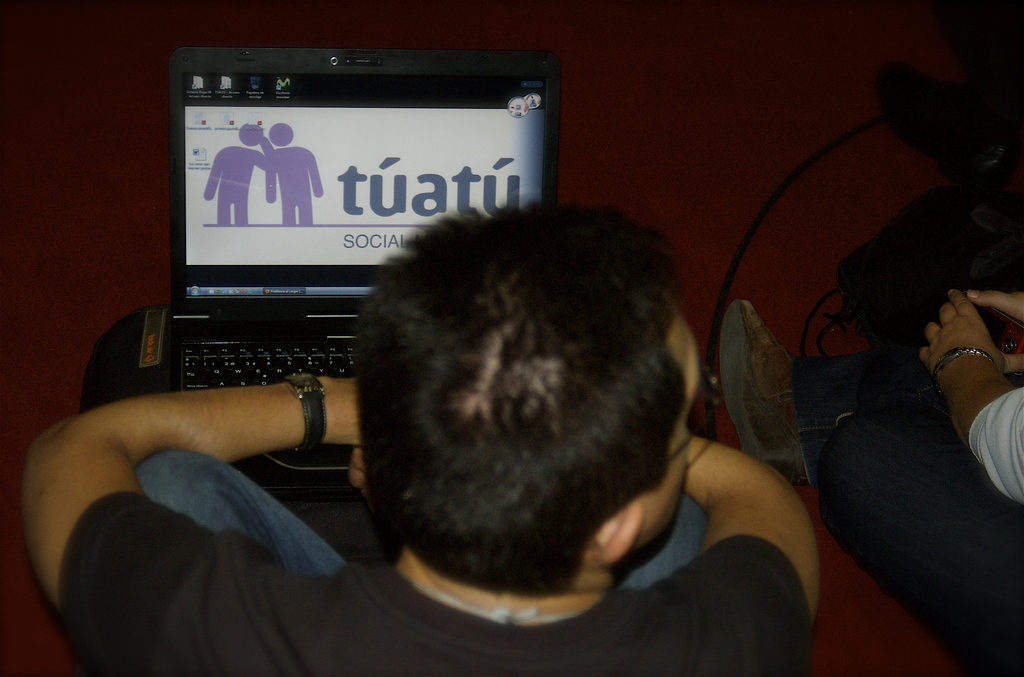Describe the setting in which the man is using his laptop. The man is seated in a casual, possibly public setting with a carpeted floor and ambient lighting, indicative of a relaxed environment like a lounge or a student common area. Does the setting seem to affect his interaction with the website? The relaxed setting likely promotes a comfortable browsing experience, potentially enabling longer engagement periods with the website without the formalities or distractions typically present in a more conventional workplace. 